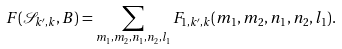Convert formula to latex. <formula><loc_0><loc_0><loc_500><loc_500>F ( \mathcal { S } _ { k ^ { \prime } , k } , B ) = \sum _ { m _ { 1 } , m _ { 2 } , n _ { 1 } , n _ { 2 } , l _ { 1 } } F _ { 1 , k ^ { \prime } , k } ( m _ { 1 } , m _ { 2 } , n _ { 1 } , n _ { 2 } , l _ { 1 } ) .</formula> 